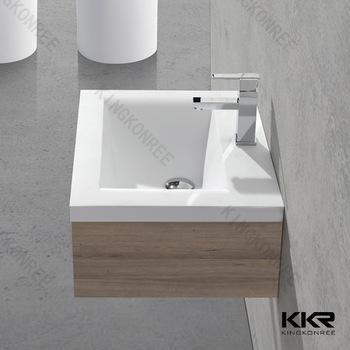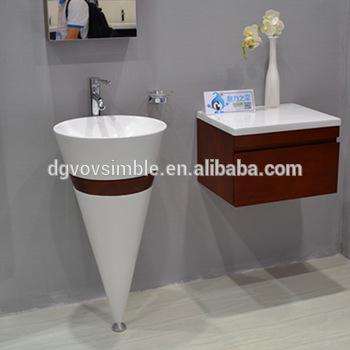The first image is the image on the left, the second image is the image on the right. For the images shown, is this caption "There is one oval shaped sink and one rectangle shaped sink attached to the wall." true? Answer yes or no. No. The first image is the image on the left, the second image is the image on the right. Considering the images on both sides, is "An image features a wall-mounted semi-circle white sinkwith chrome dispenser on top." valid? Answer yes or no. No. 